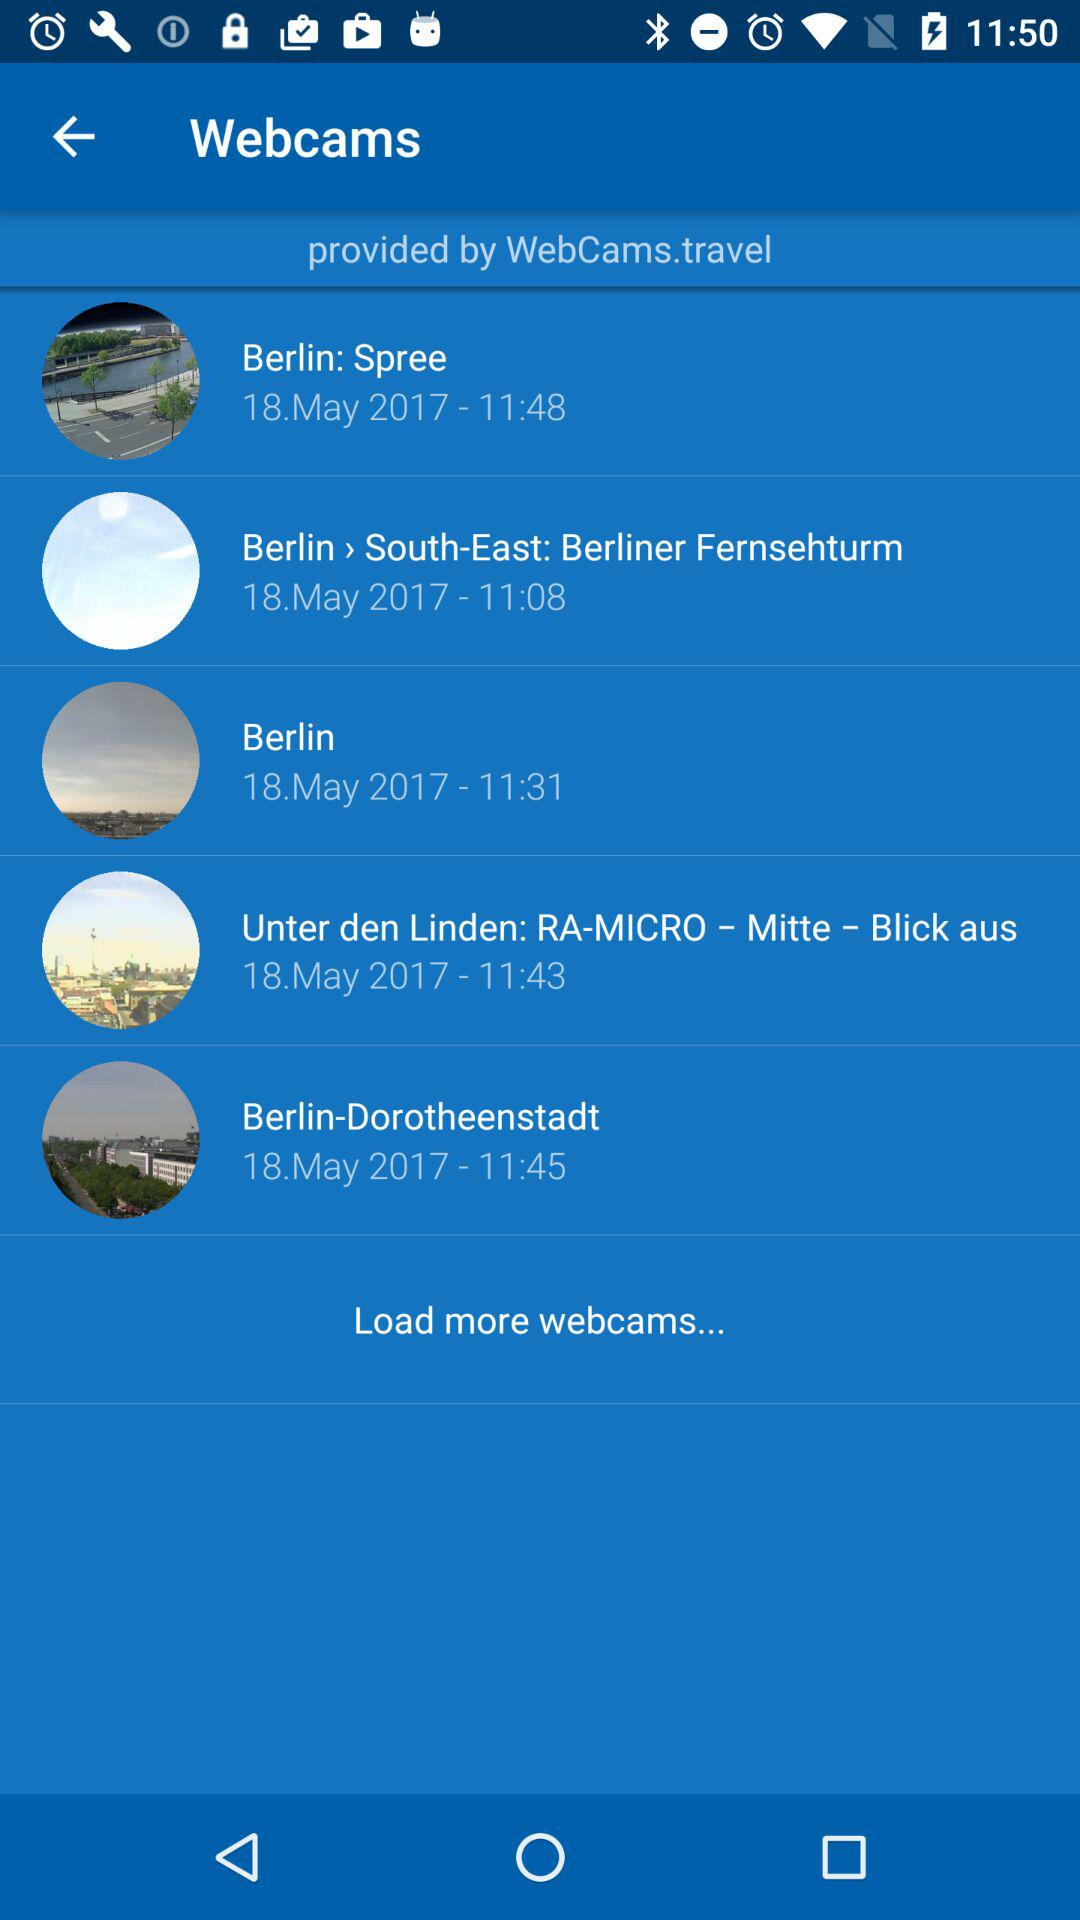What is the date of Berlin? The date of Berlin is May 18, 2017. 